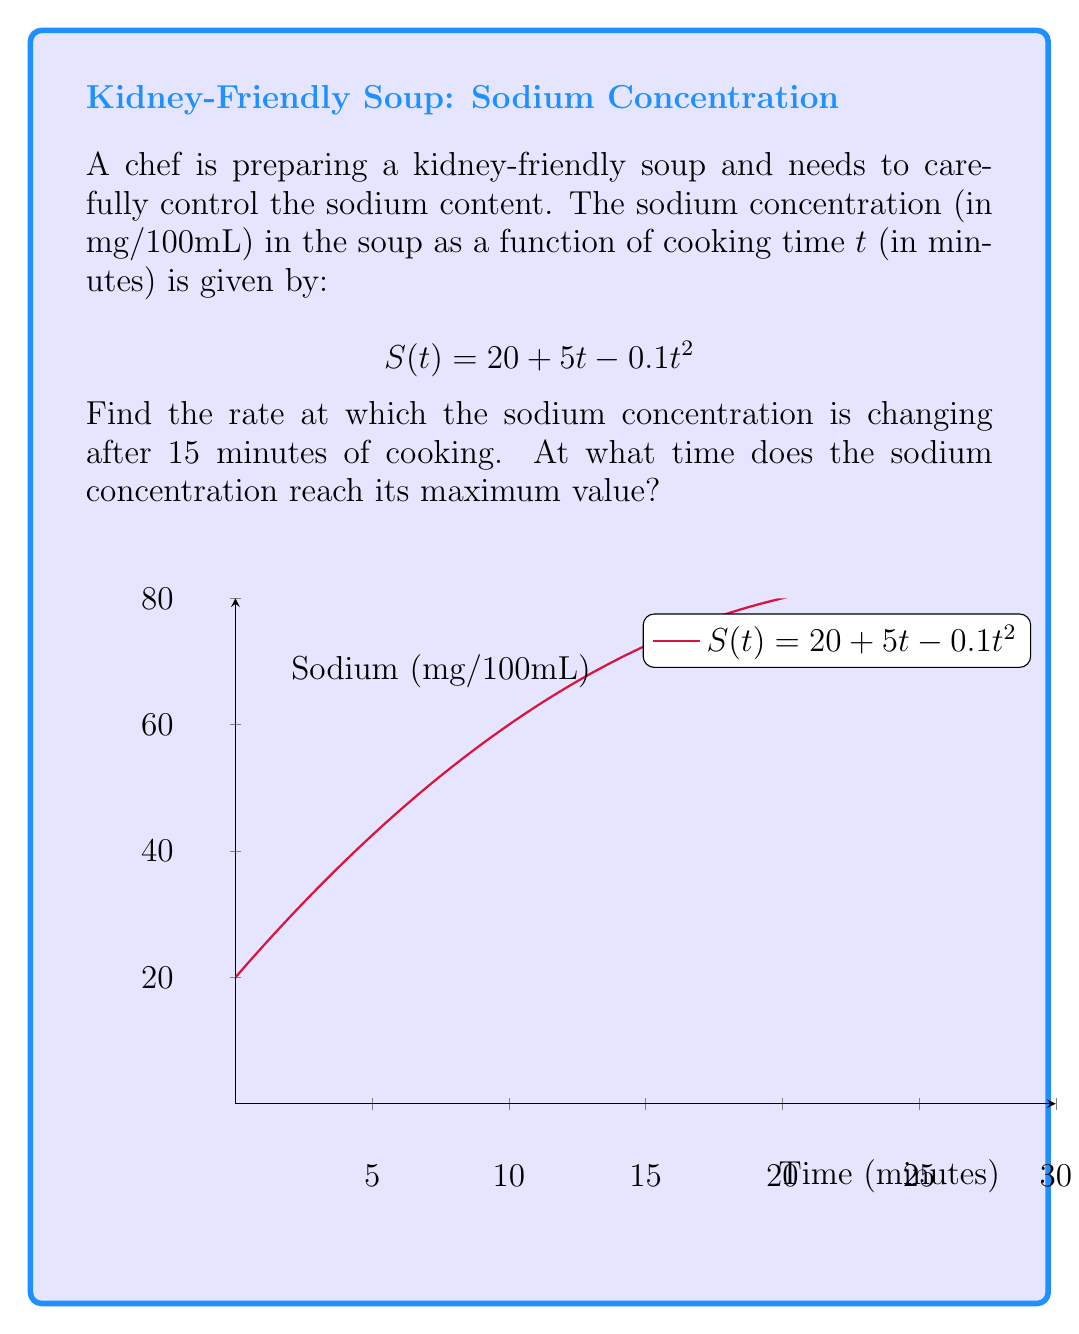Provide a solution to this math problem. Let's approach this step-by-step:

1) To find the rate of change of sodium concentration, we need to find the derivative of S(t) with respect to t.

   $$S'(t) = \frac{d}{dt}(20 + 5t - 0.1t^2) = 5 - 0.2t$$

2) To find the rate of change at t = 15 minutes, we substitute t = 15 into S'(t):

   $$S'(15) = 5 - 0.2(15) = 5 - 3 = 2$$

3) To find the time when sodium concentration reaches its maximum, we need to find where S'(t) = 0:

   $$5 - 0.2t = 0$$
   $$-0.2t = -5$$
   $$t = 25$$

4) To confirm this is a maximum (not a minimum), we can check the second derivative:

   $$S''(t) = \frac{d}{dt}(5 - 0.2t) = -0.2$$

   Since S''(t) is negative, this confirms t = 25 gives a maximum.

5) We can also interpret this geometrically: the parabola opens downward because the coefficient of t^2 is negative, so it has a maximum, not a minimum.
Answer: 2 mg/100mL per minute at t = 15; maximum at t = 25 minutes 